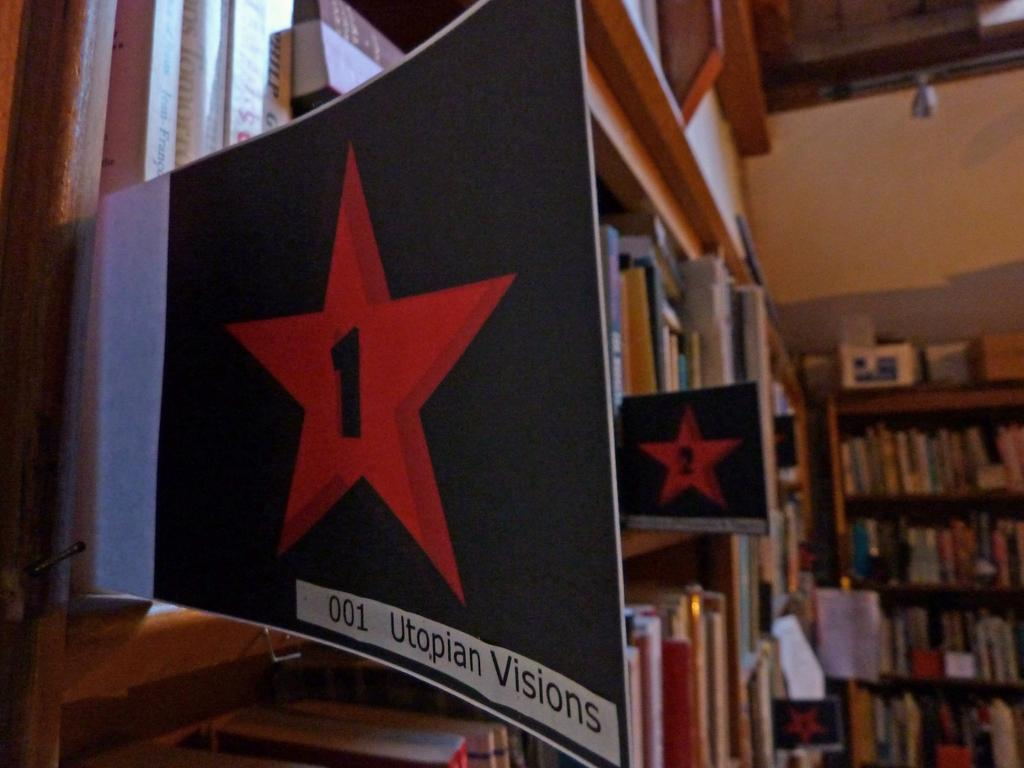Provide a one-sentence caption for the provided image. A packed group of shelves with signs that say Utopian Visions. 